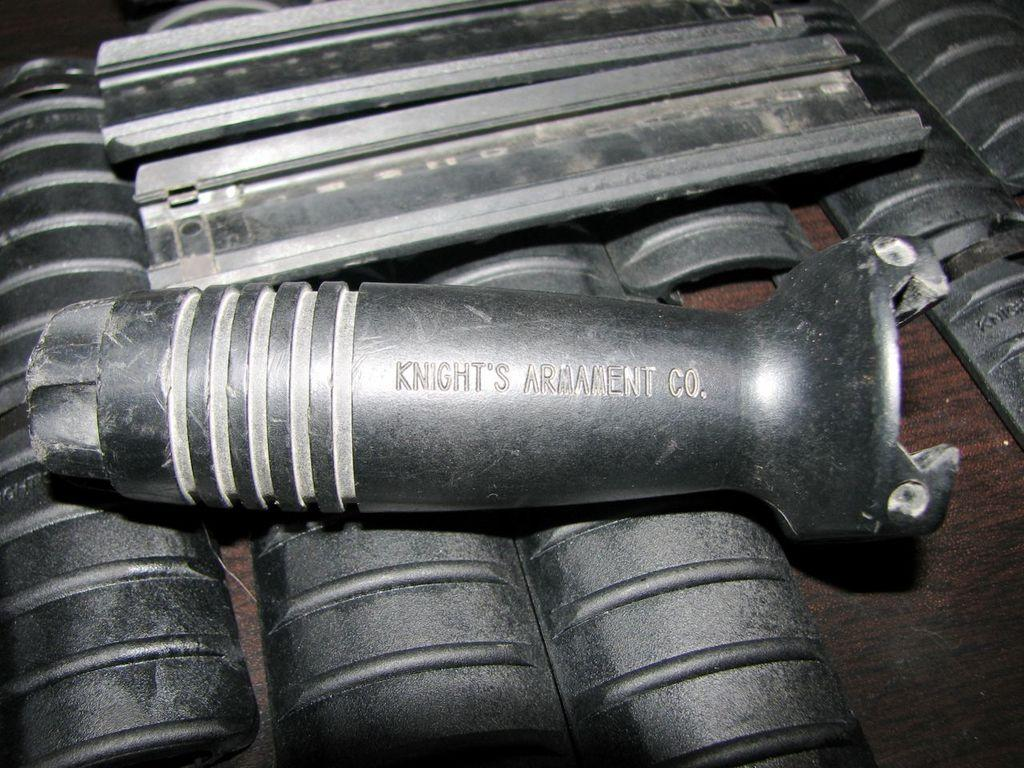What is located at the bottom of the image? There is a table at the bottom of the image. What type of objects are on the table? There are metal objects on the table. How many marbles are on the table in the image? There is no mention of marbles in the image; only metal objects are described. Can you see any cats or babies on the table in the image? There is no mention of cats or babies in the image; only a table and metal objects are described. 